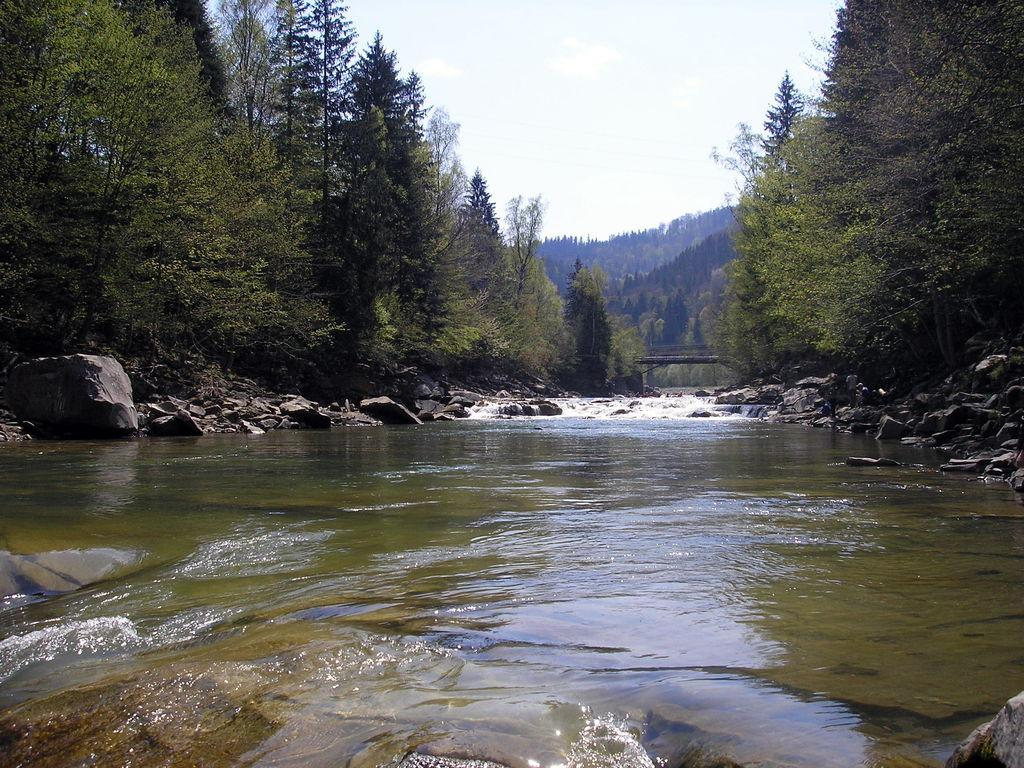What is present in the front of the image? There is water in the front of the image. What can be seen in the background of the image? There are stones and trees in the background of the image. How would you describe the sky in the image? The sky is cloudy in the image. What type of attraction can be seen in the image? There is no attraction present in the image; it features water, stones, trees, and a cloudy sky. Can you tell me if there is any evidence of a crush in the image? There is no indication of a crush or any romantic context in the image. 